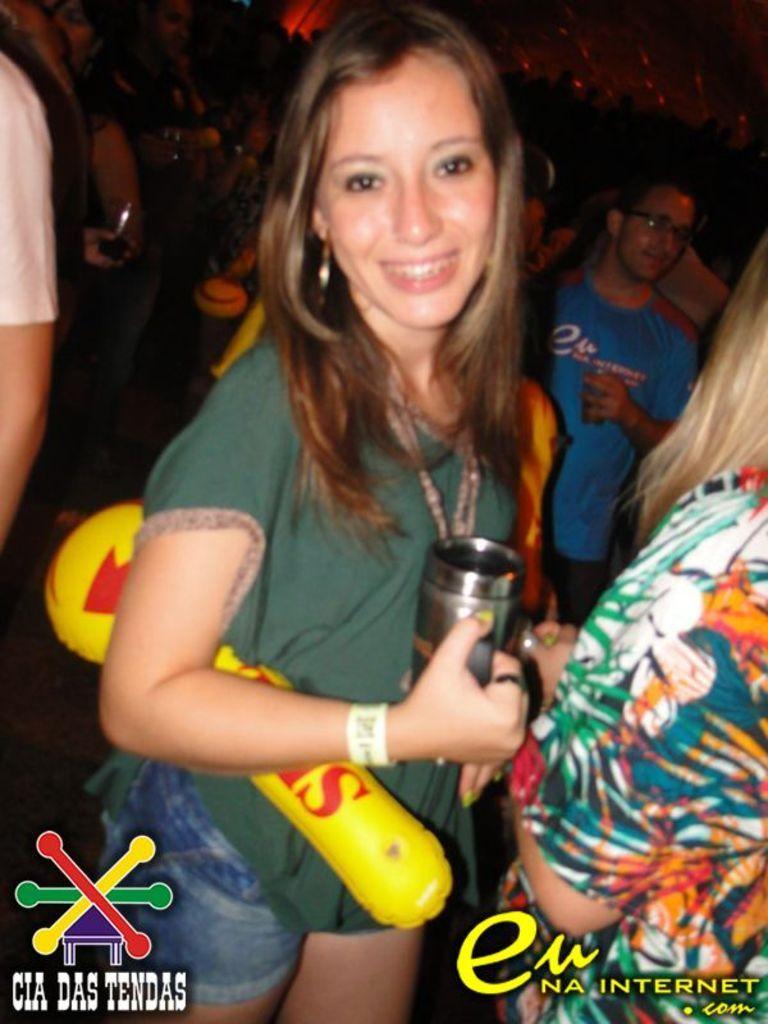How would you summarize this image in a sentence or two? In the center of the image there is a lady wearing a green color dress. She is holding a cup in her hand. Besides her there is another lady. In the background of the image there are many persons. At the bottom of the image there is some written text. 